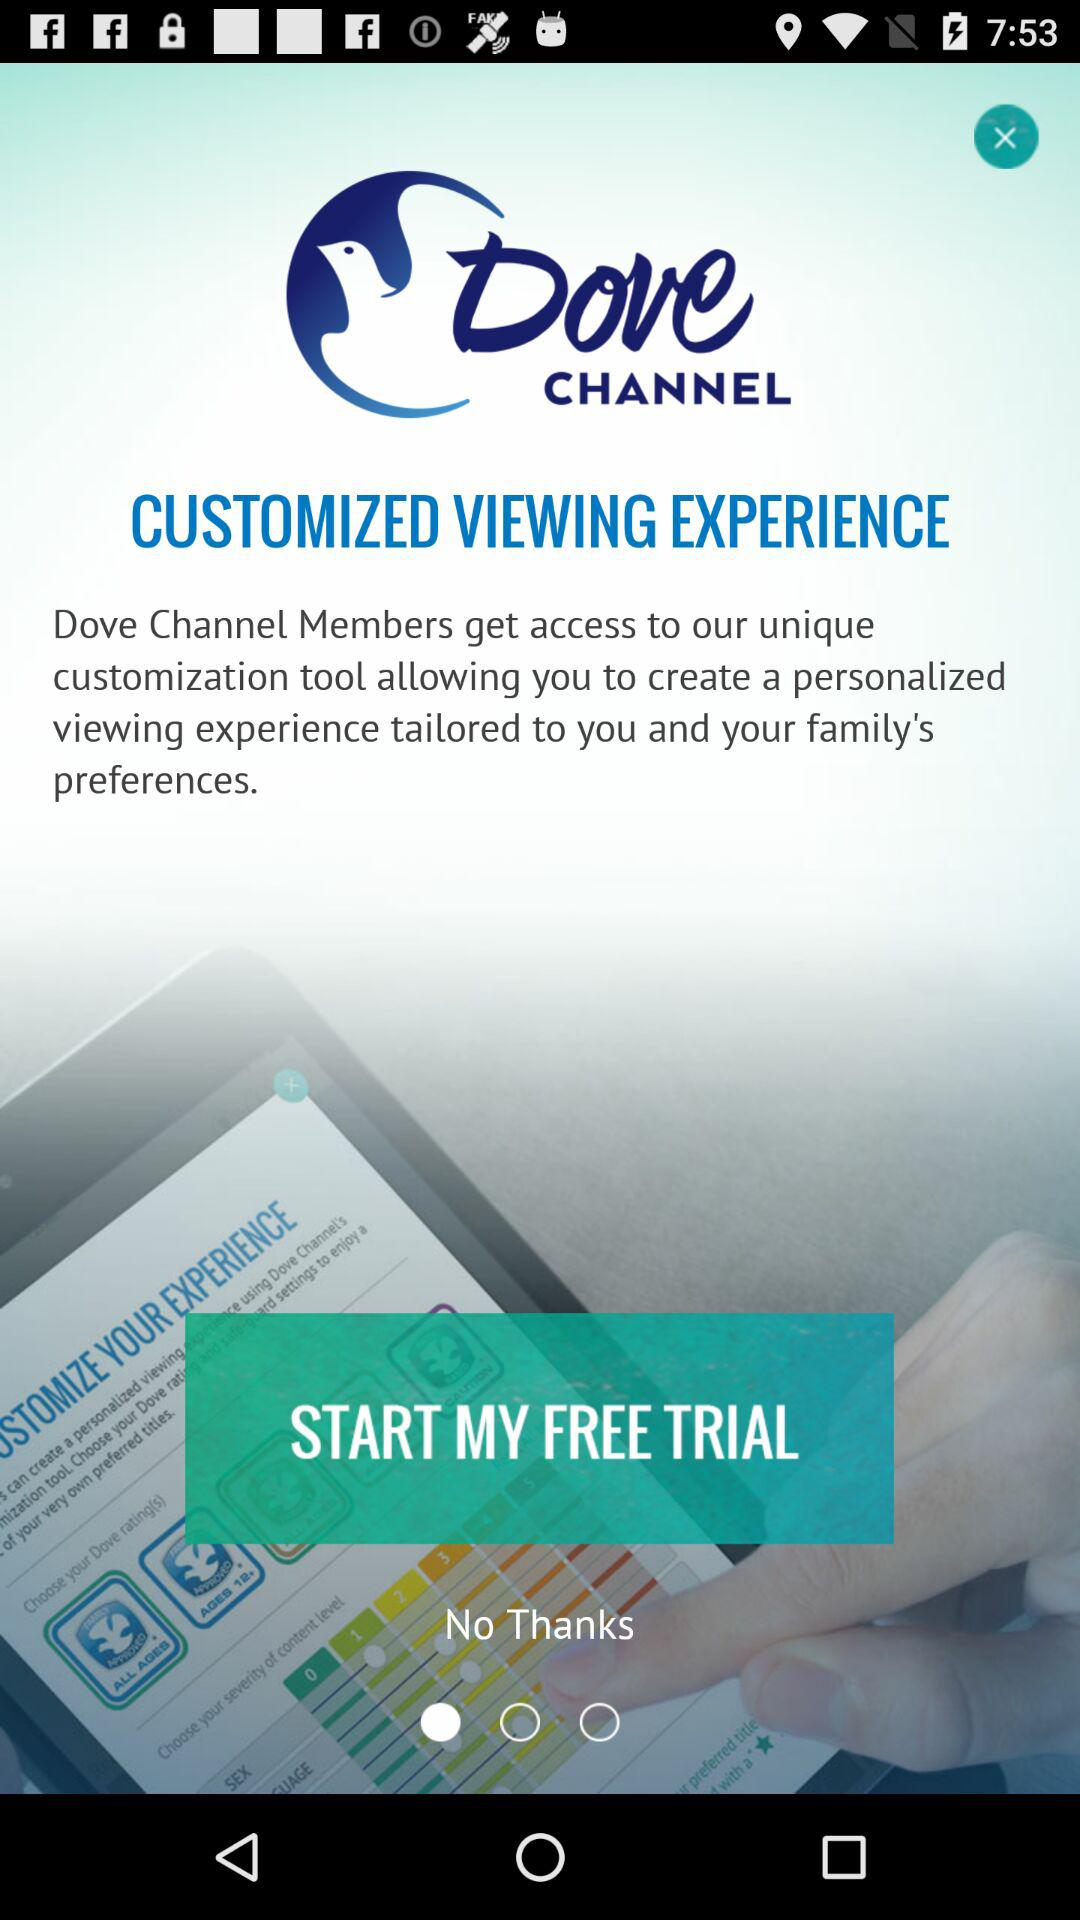What is the name of the application? The name of the application is "Dove CHANNEL". 